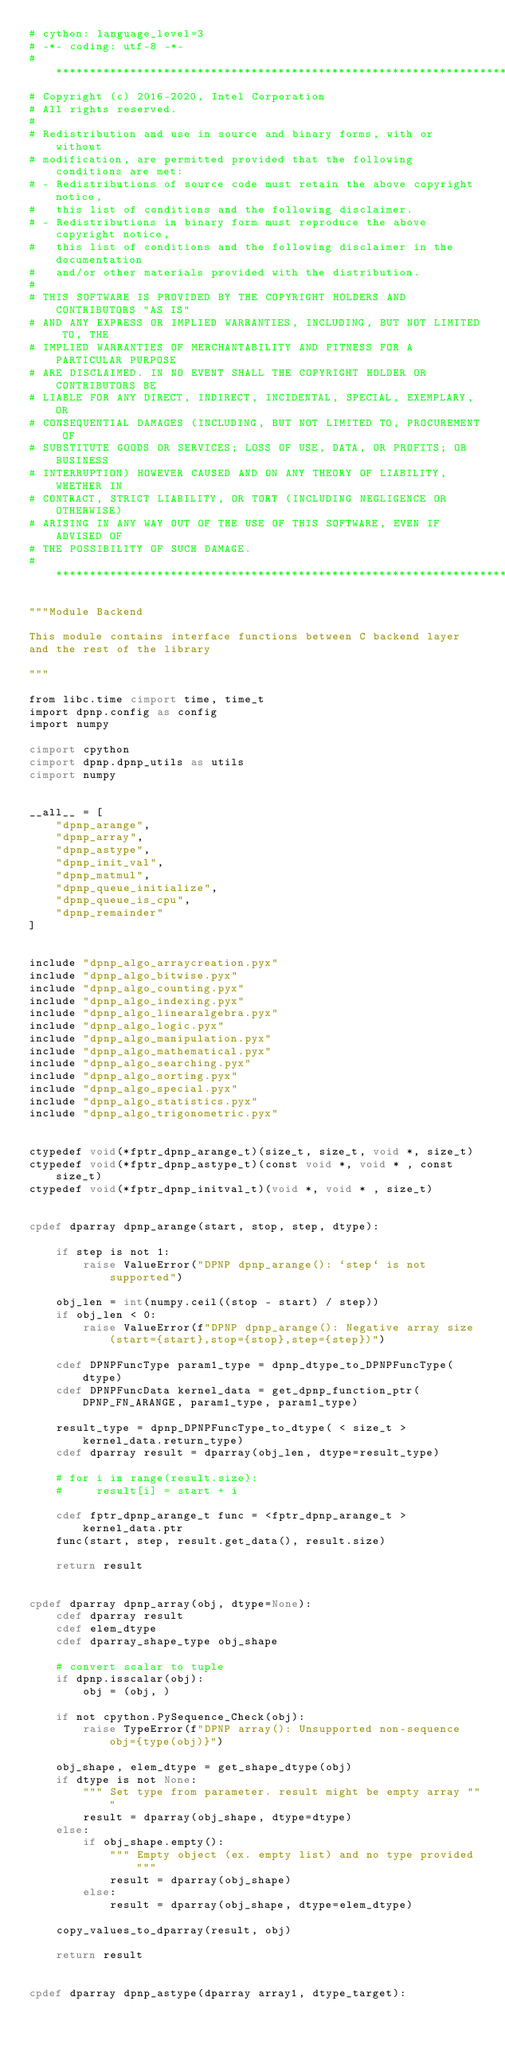<code> <loc_0><loc_0><loc_500><loc_500><_Cython_># cython: language_level=3
# -*- coding: utf-8 -*-
# *****************************************************************************
# Copyright (c) 2016-2020, Intel Corporation
# All rights reserved.
#
# Redistribution and use in source and binary forms, with or without
# modification, are permitted provided that the following conditions are met:
# - Redistributions of source code must retain the above copyright notice,
#   this list of conditions and the following disclaimer.
# - Redistributions in binary form must reproduce the above copyright notice,
#   this list of conditions and the following disclaimer in the documentation
#   and/or other materials provided with the distribution.
#
# THIS SOFTWARE IS PROVIDED BY THE COPYRIGHT HOLDERS AND CONTRIBUTORS "AS IS"
# AND ANY EXPRESS OR IMPLIED WARRANTIES, INCLUDING, BUT NOT LIMITED TO, THE
# IMPLIED WARRANTIES OF MERCHANTABILITY AND FITNESS FOR A PARTICULAR PURPOSE
# ARE DISCLAIMED. IN NO EVENT SHALL THE COPYRIGHT HOLDER OR CONTRIBUTORS BE
# LIABLE FOR ANY DIRECT, INDIRECT, INCIDENTAL, SPECIAL, EXEMPLARY, OR
# CONSEQUENTIAL DAMAGES (INCLUDING, BUT NOT LIMITED TO, PROCUREMENT OF
# SUBSTITUTE GOODS OR SERVICES; LOSS OF USE, DATA, OR PROFITS; OR BUSINESS
# INTERRUPTION) HOWEVER CAUSED AND ON ANY THEORY OF LIABILITY, WHETHER IN
# CONTRACT, STRICT LIABILITY, OR TORT (INCLUDING NEGLIGENCE OR OTHERWISE)
# ARISING IN ANY WAY OUT OF THE USE OF THIS SOFTWARE, EVEN IF ADVISED OF
# THE POSSIBILITY OF SUCH DAMAGE.
# *****************************************************************************

"""Module Backend

This module contains interface functions between C backend layer
and the rest of the library

"""

from libc.time cimport time, time_t
import dpnp.config as config
import numpy

cimport cpython
cimport dpnp.dpnp_utils as utils
cimport numpy


__all__ = [
    "dpnp_arange",
    "dpnp_array",
    "dpnp_astype",
    "dpnp_init_val",
    "dpnp_matmul",
    "dpnp_queue_initialize",
    "dpnp_queue_is_cpu",
    "dpnp_remainder"
]


include "dpnp_algo_arraycreation.pyx"
include "dpnp_algo_bitwise.pyx"
include "dpnp_algo_counting.pyx"
include "dpnp_algo_indexing.pyx"
include "dpnp_algo_linearalgebra.pyx"
include "dpnp_algo_logic.pyx"
include "dpnp_algo_manipulation.pyx"
include "dpnp_algo_mathematical.pyx"
include "dpnp_algo_searching.pyx"
include "dpnp_algo_sorting.pyx"
include "dpnp_algo_special.pyx"
include "dpnp_algo_statistics.pyx"
include "dpnp_algo_trigonometric.pyx"


ctypedef void(*fptr_dpnp_arange_t)(size_t, size_t, void *, size_t)
ctypedef void(*fptr_dpnp_astype_t)(const void *, void * , const size_t)
ctypedef void(*fptr_dpnp_initval_t)(void *, void * , size_t)


cpdef dparray dpnp_arange(start, stop, step, dtype):

    if step is not 1:
        raise ValueError("DPNP dpnp_arange(): `step` is not supported")

    obj_len = int(numpy.ceil((stop - start) / step))
    if obj_len < 0:
        raise ValueError(f"DPNP dpnp_arange(): Negative array size (start={start},stop={stop},step={step})")

    cdef DPNPFuncType param1_type = dpnp_dtype_to_DPNPFuncType(dtype)
    cdef DPNPFuncData kernel_data = get_dpnp_function_ptr(DPNP_FN_ARANGE, param1_type, param1_type)

    result_type = dpnp_DPNPFuncType_to_dtype( < size_t > kernel_data.return_type)
    cdef dparray result = dparray(obj_len, dtype=result_type)

    # for i in range(result.size):
    #     result[i] = start + i

    cdef fptr_dpnp_arange_t func = <fptr_dpnp_arange_t > kernel_data.ptr
    func(start, step, result.get_data(), result.size)

    return result


cpdef dparray dpnp_array(obj, dtype=None):
    cdef dparray result
    cdef elem_dtype
    cdef dparray_shape_type obj_shape

    # convert scalar to tuple
    if dpnp.isscalar(obj):
        obj = (obj, )

    if not cpython.PySequence_Check(obj):
        raise TypeError(f"DPNP array(): Unsupported non-sequence obj={type(obj)}")

    obj_shape, elem_dtype = get_shape_dtype(obj)
    if dtype is not None:
        """ Set type from parameter. result might be empty array """
        result = dparray(obj_shape, dtype=dtype)
    else:
        if obj_shape.empty():
            """ Empty object (ex. empty list) and no type provided """
            result = dparray(obj_shape)
        else:
            result = dparray(obj_shape, dtype=elem_dtype)

    copy_values_to_dparray(result, obj)

    return result


cpdef dparray dpnp_astype(dparray array1, dtype_target):</code> 